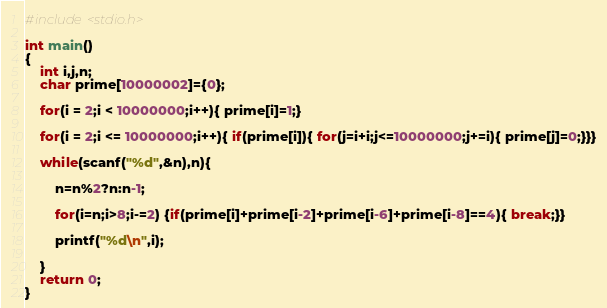<code> <loc_0><loc_0><loc_500><loc_500><_C_>#include<stdio.h>

int main()
{
    int i,j,n;
    char prime[10000002]={0};

    for(i = 2;i < 10000000;i++){ prime[i]=1;}

    for(i = 2;i <= 10000000;i++){ if(prime[i]){ for(j=i+i;j<=10000000;j+=i){ prime[j]=0;}}}

    while(scanf("%d",&n),n){

        n=n%2?n:n-1;

        for(i=n;i>8;i-=2) {if(prime[i]+prime[i-2]+prime[i-6]+prime[i-8]==4){ break;}}

        printf("%d\n",i);

    }   
    return 0;
}</code> 